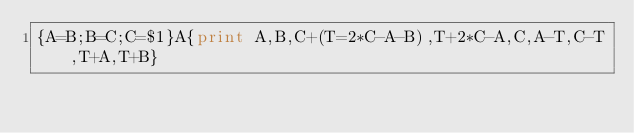Convert code to text. <code><loc_0><loc_0><loc_500><loc_500><_Awk_>{A=B;B=C;C=$1}A{print A,B,C+(T=2*C-A-B),T+2*C-A,C,A-T,C-T,T+A,T+B}</code> 